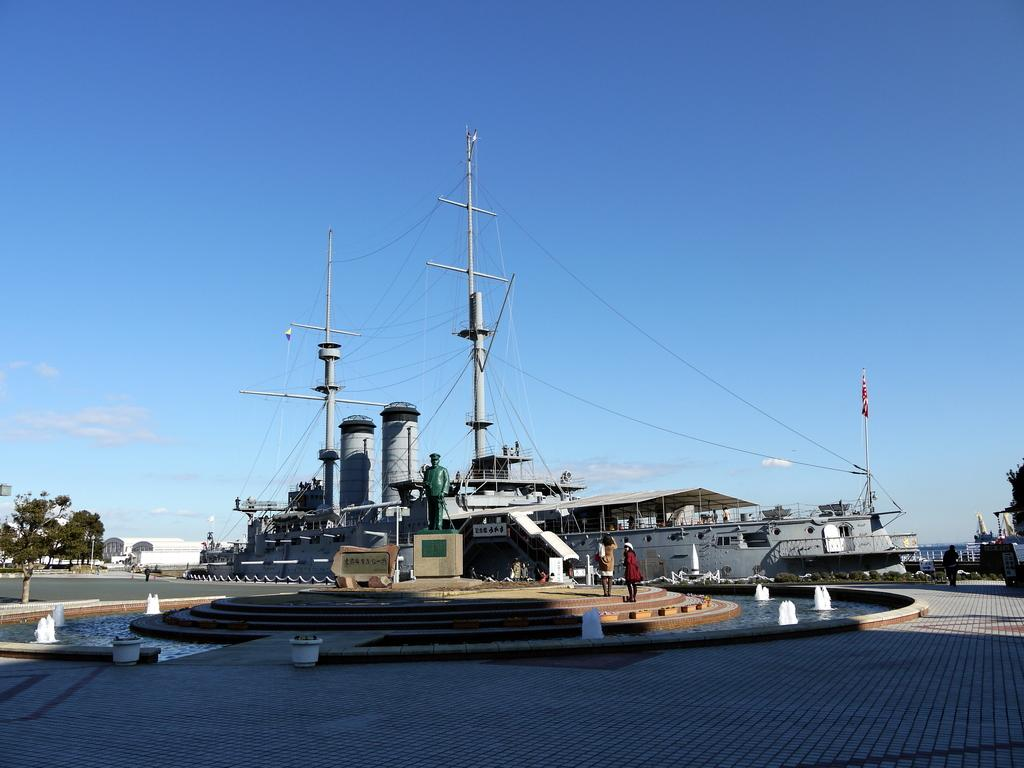What type of vehicles can be seen in the image? There are boats in the image. What other object is present in the image besides the boats? There is a statue in the image. Can you describe the people in the image? There are people in the image. What architectural feature is visible in the image? There are stairs in the image. What structures are used to guide the boats in the image? Current poles are present in the image. What type of vegetation is visible in the image? Trees are visible in the image. What is visible at the top of the image? The sky is visible at the top of the image. How does the liquid flow around the rabbit in the image? There is no liquid or rabbit present in the image. How does the increase in boat traffic affect the current poles in the image? There is no mention of an increase in boat traffic in the provided facts, and the current poles are stationary structures. 